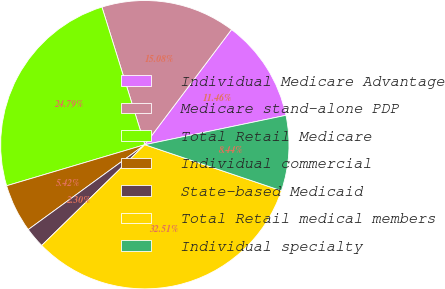Convert chart. <chart><loc_0><loc_0><loc_500><loc_500><pie_chart><fcel>Individual Medicare Advantage<fcel>Medicare stand-alone PDP<fcel>Total Retail Medicare<fcel>Individual commercial<fcel>State-based Medicaid<fcel>Total Retail medical members<fcel>Individual specialty<nl><fcel>11.46%<fcel>15.08%<fcel>24.79%<fcel>5.42%<fcel>2.3%<fcel>32.51%<fcel>8.44%<nl></chart> 